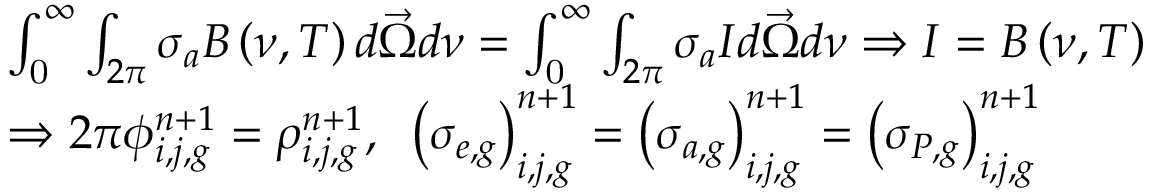Convert formula to latex. <formula><loc_0><loc_0><loc_500><loc_500>\begin{array} { l } { { \int _ { 0 } ^ { \infty } \int _ { 2 \pi } \sigma _ { a } B \left ( \nu , T \right ) d \vec { \Omega } d \nu = \int _ { 0 } ^ { \infty } \int _ { 2 \pi } \sigma _ { a } I d \vec { \Omega } d \nu \Rightarrow I = B \left ( \nu , T \right ) } } \\ { { \Rightarrow 2 \pi \phi _ { i , j , g } ^ { n + 1 } = \rho _ { i , j , g } ^ { n + 1 } , \, \left ( \sigma _ { e , g } \right ) _ { i , j , g } ^ { n + 1 } = \left ( \sigma _ { a , g } \right ) _ { i , j , g } ^ { n + 1 } = \left ( \sigma _ { P , g } \right ) _ { i , j , g } ^ { n + 1 } } } \end{array}</formula> 